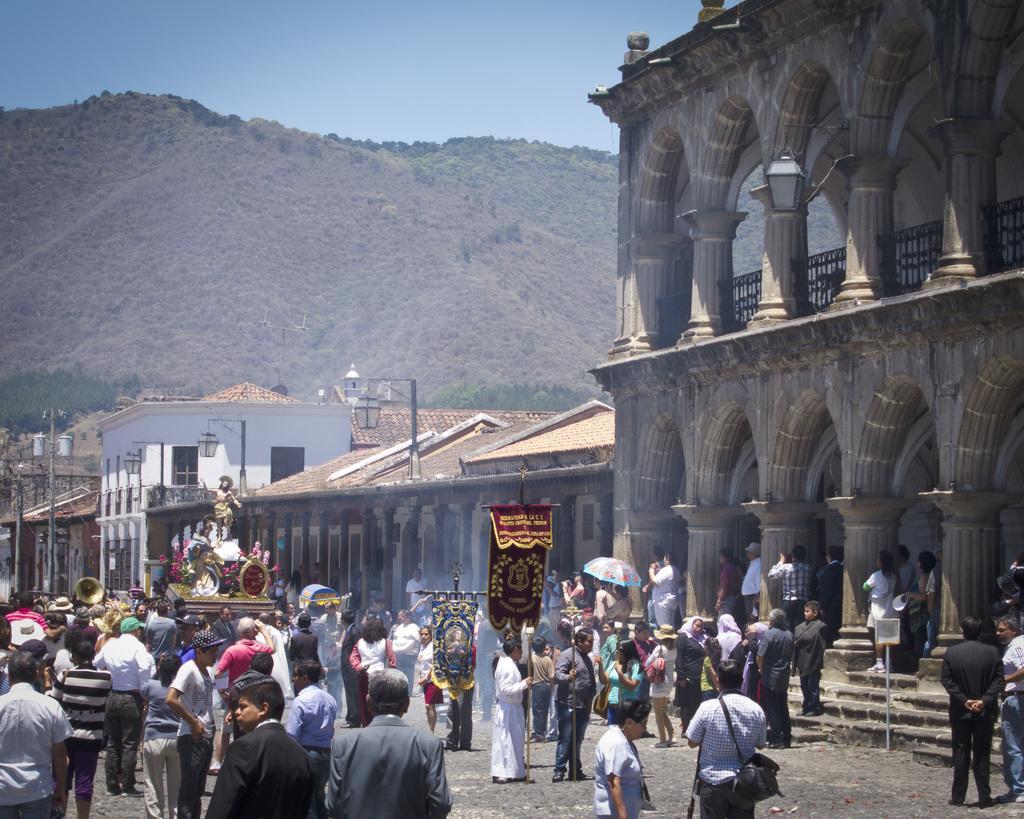Could you give a brief overview of what you see in this image? As we can see in the image there are few people here and there, stairs, buildings, statue, street lamps, hills and sky. 